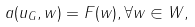<formula> <loc_0><loc_0><loc_500><loc_500>a ( u _ { G } , w ) = F ( w ) , \forall w \in W ,</formula> 